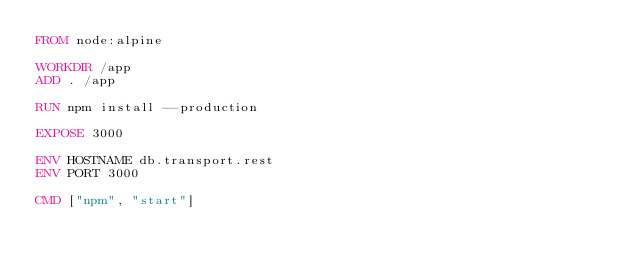Convert code to text. <code><loc_0><loc_0><loc_500><loc_500><_Dockerfile_>FROM node:alpine

WORKDIR /app
ADD . /app

RUN npm install --production

EXPOSE 3000

ENV HOSTNAME db.transport.rest
ENV PORT 3000

CMD ["npm", "start"]
</code> 